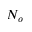<formula> <loc_0><loc_0><loc_500><loc_500>N _ { o }</formula> 